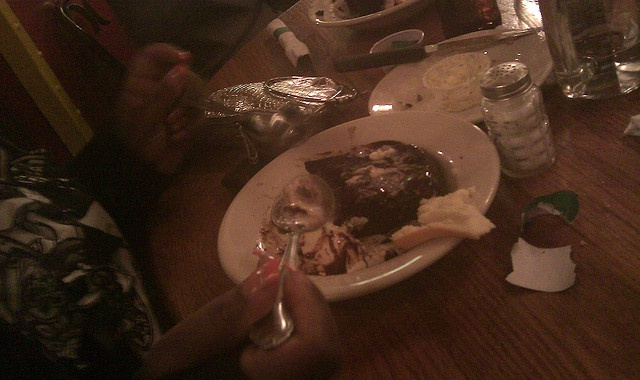Describe the objects in this image and their specific colors. I can see dining table in maroon, black, and brown tones, people in maroon, black, and brown tones, bowl in maroon and brown tones, handbag in maroon, black, and gray tones, and cake in maroon, black, and brown tones in this image. 